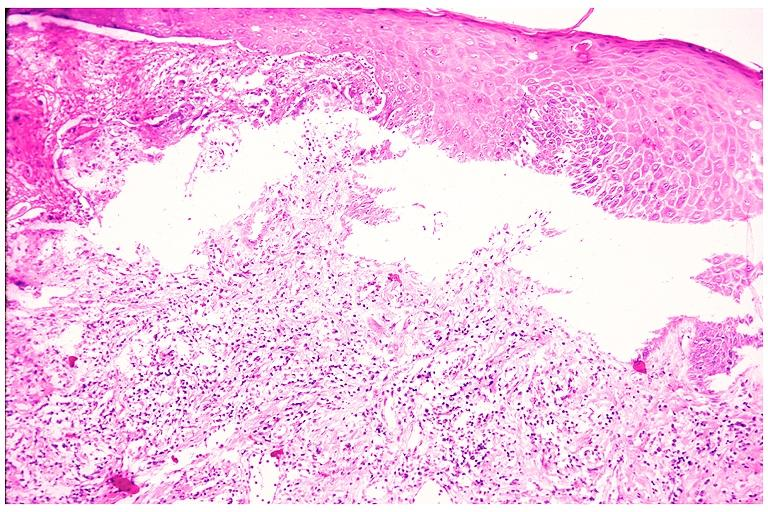what does this image show?
Answer the question using a single word or phrase. Cicatricial pemphigoid 